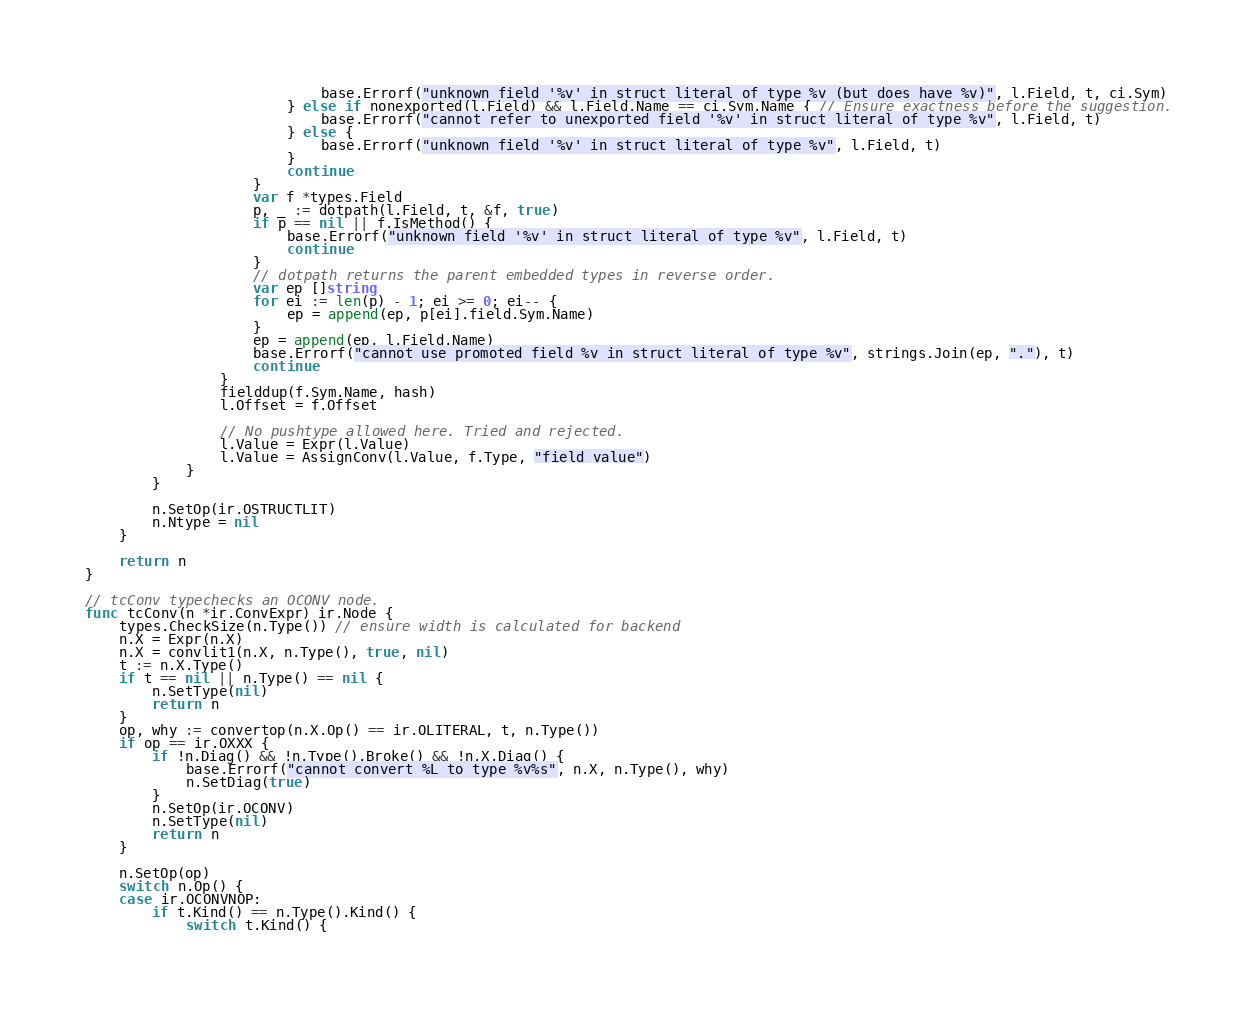<code> <loc_0><loc_0><loc_500><loc_500><_Go_>							base.Errorf("unknown field '%v' in struct literal of type %v (but does have %v)", l.Field, t, ci.Sym)
						} else if nonexported(l.Field) && l.Field.Name == ci.Sym.Name { // Ensure exactness before the suggestion.
							base.Errorf("cannot refer to unexported field '%v' in struct literal of type %v", l.Field, t)
						} else {
							base.Errorf("unknown field '%v' in struct literal of type %v", l.Field, t)
						}
						continue
					}
					var f *types.Field
					p, _ := dotpath(l.Field, t, &f, true)
					if p == nil || f.IsMethod() {
						base.Errorf("unknown field '%v' in struct literal of type %v", l.Field, t)
						continue
					}
					// dotpath returns the parent embedded types in reverse order.
					var ep []string
					for ei := len(p) - 1; ei >= 0; ei-- {
						ep = append(ep, p[ei].field.Sym.Name)
					}
					ep = append(ep, l.Field.Name)
					base.Errorf("cannot use promoted field %v in struct literal of type %v", strings.Join(ep, "."), t)
					continue
				}
				fielddup(f.Sym.Name, hash)
				l.Offset = f.Offset

				// No pushtype allowed here. Tried and rejected.
				l.Value = Expr(l.Value)
				l.Value = AssignConv(l.Value, f.Type, "field value")
			}
		}

		n.SetOp(ir.OSTRUCTLIT)
		n.Ntype = nil
	}

	return n
}

// tcConv typechecks an OCONV node.
func tcConv(n *ir.ConvExpr) ir.Node {
	types.CheckSize(n.Type()) // ensure width is calculated for backend
	n.X = Expr(n.X)
	n.X = convlit1(n.X, n.Type(), true, nil)
	t := n.X.Type()
	if t == nil || n.Type() == nil {
		n.SetType(nil)
		return n
	}
	op, why := convertop(n.X.Op() == ir.OLITERAL, t, n.Type())
	if op == ir.OXXX {
		if !n.Diag() && !n.Type().Broke() && !n.X.Diag() {
			base.Errorf("cannot convert %L to type %v%s", n.X, n.Type(), why)
			n.SetDiag(true)
		}
		n.SetOp(ir.OCONV)
		n.SetType(nil)
		return n
	}

	n.SetOp(op)
	switch n.Op() {
	case ir.OCONVNOP:
		if t.Kind() == n.Type().Kind() {
			switch t.Kind() {</code> 